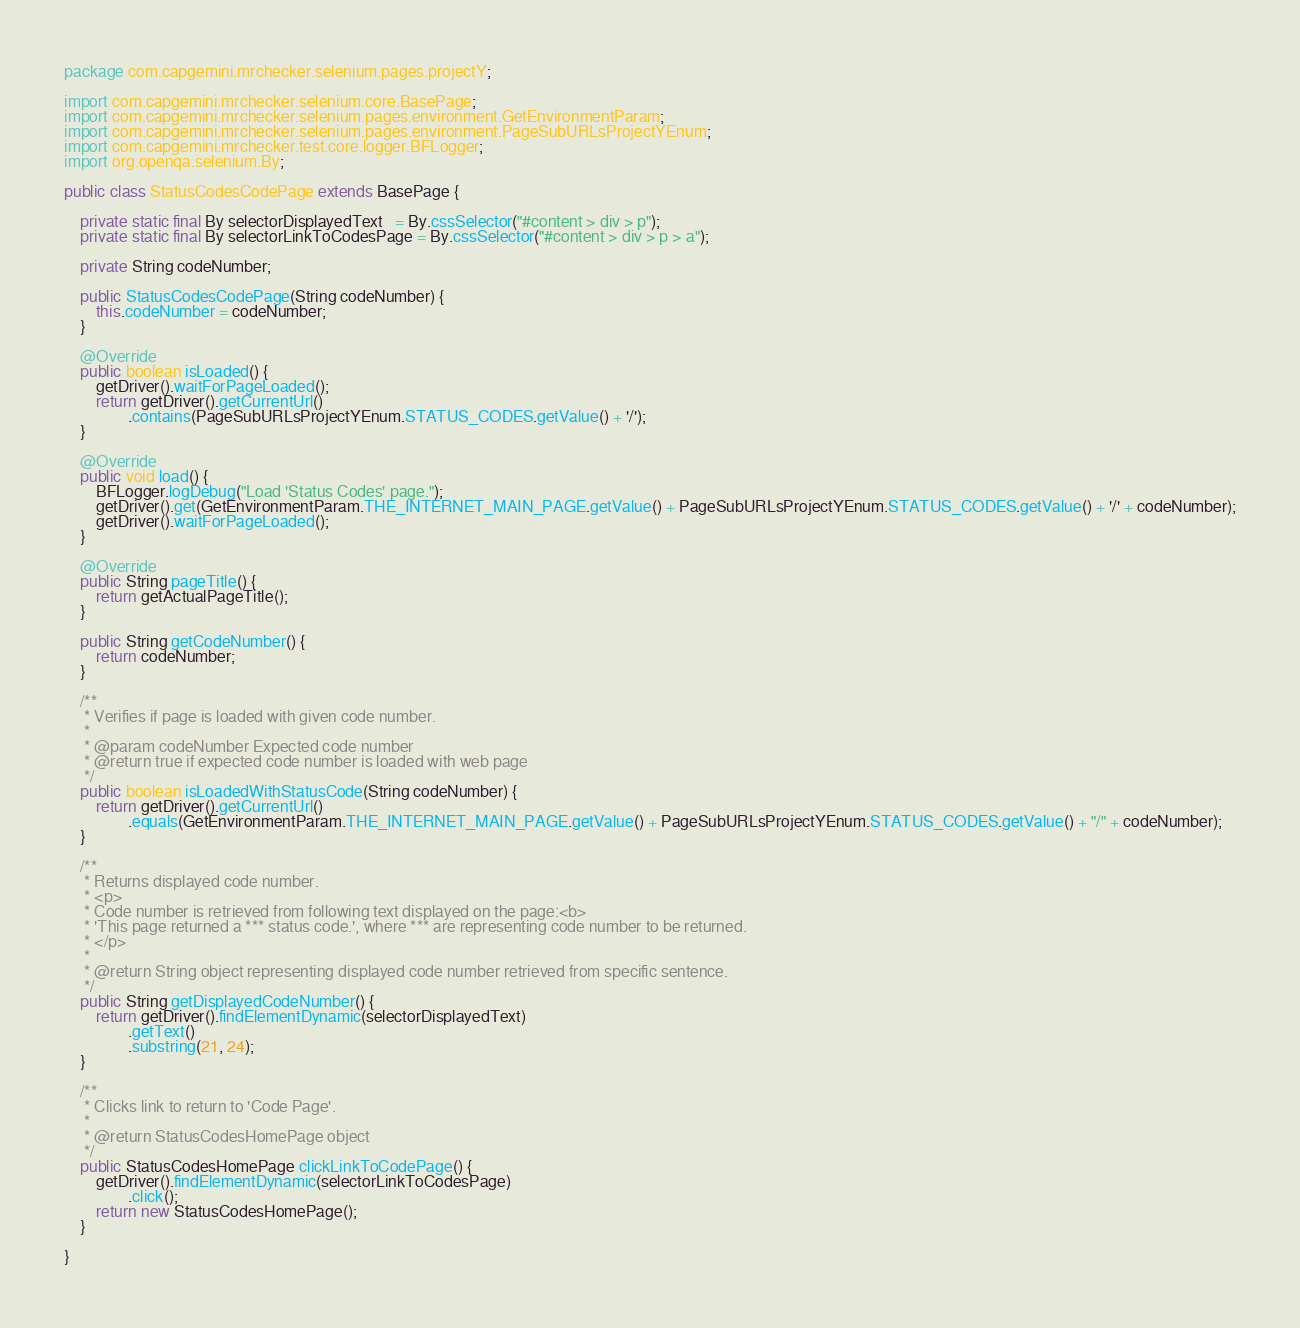<code> <loc_0><loc_0><loc_500><loc_500><_Java_>package com.capgemini.mrchecker.selenium.pages.projectY;

import com.capgemini.mrchecker.selenium.core.BasePage;
import com.capgemini.mrchecker.selenium.pages.environment.GetEnvironmentParam;
import com.capgemini.mrchecker.selenium.pages.environment.PageSubURLsProjectYEnum;
import com.capgemini.mrchecker.test.core.logger.BFLogger;
import org.openqa.selenium.By;

public class StatusCodesCodePage extends BasePage {

	private static final By selectorDisplayedText   = By.cssSelector("#content > div > p");
	private static final By selectorLinkToCodesPage = By.cssSelector("#content > div > p > a");

	private String codeNumber;

	public StatusCodesCodePage(String codeNumber) {
		this.codeNumber = codeNumber;
	}

	@Override
	public boolean isLoaded() {
		getDriver().waitForPageLoaded();
		return getDriver().getCurrentUrl()
				.contains(PageSubURLsProjectYEnum.STATUS_CODES.getValue() + '/');
	}

	@Override
	public void load() {
		BFLogger.logDebug("Load 'Status Codes' page.");
		getDriver().get(GetEnvironmentParam.THE_INTERNET_MAIN_PAGE.getValue() + PageSubURLsProjectYEnum.STATUS_CODES.getValue() + '/' + codeNumber);
		getDriver().waitForPageLoaded();
	}

	@Override
	public String pageTitle() {
		return getActualPageTitle();
	}

	public String getCodeNumber() {
		return codeNumber;
	}

	/**
	 * Verifies if page is loaded with given code number.
	 *
	 * @param codeNumber Expected code number
	 * @return true if expected code number is loaded with web page
	 */
	public boolean isLoadedWithStatusCode(String codeNumber) {
		return getDriver().getCurrentUrl()
				.equals(GetEnvironmentParam.THE_INTERNET_MAIN_PAGE.getValue() + PageSubURLsProjectYEnum.STATUS_CODES.getValue() + "/" + codeNumber);
	}

	/**
	 * Returns displayed code number.
	 * <p>
	 * Code number is retrieved from following text displayed on the page:<b>
	 * 'This page returned a *** status code.', where *** are representing code number to be returned.
	 * </p>
	 *
	 * @return String object representing displayed code number retrieved from specific sentence.
	 */
	public String getDisplayedCodeNumber() {
		return getDriver().findElementDynamic(selectorDisplayedText)
				.getText()
				.substring(21, 24);
	}

	/**
	 * Clicks link to return to 'Code Page'.
	 *
	 * @return StatusCodesHomePage object
	 */
	public StatusCodesHomePage clickLinkToCodePage() {
		getDriver().findElementDynamic(selectorLinkToCodesPage)
				.click();
		return new StatusCodesHomePage();
	}

}</code> 